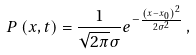Convert formula to latex. <formula><loc_0><loc_0><loc_500><loc_500>P \left ( x , t \right ) = \frac { 1 } { \sqrt { 2 \pi } \sigma } e ^ { - \frac { \left ( x - x _ { 0 } \right ) ^ { 2 } } { 2 \sigma ^ { 2 } } } \, ,</formula> 